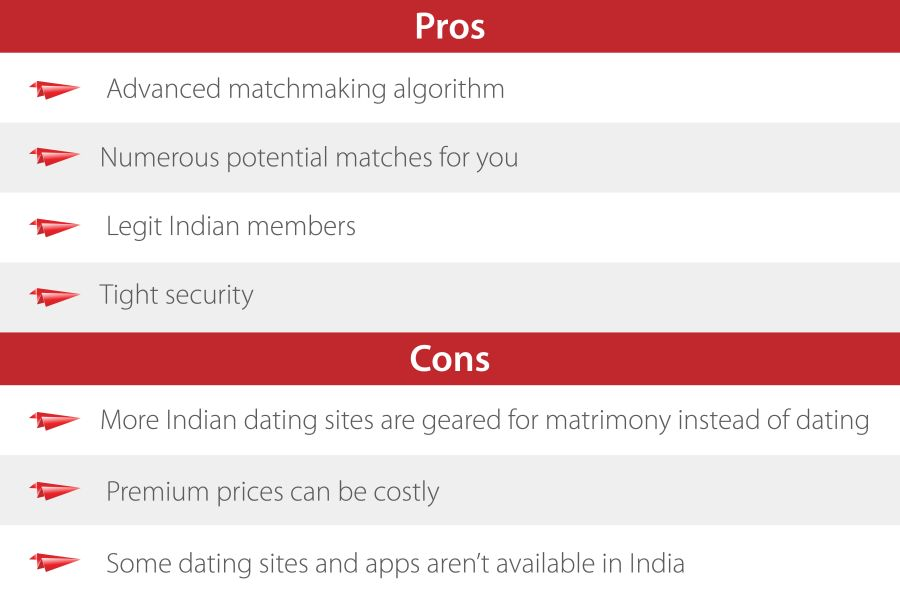Considering the 'Cons' listed, how might the focus on matrimony over dating impact the user experience? A focus on matrimony over casual dating could significantly shape the user experience by attracting users who are looking for serious commitments rather than temporary or casual encounters. This might limit the user base to individuals who have long-term relationship goals, potentially alienating those not ready for marriage or preferring less committed interactions. 